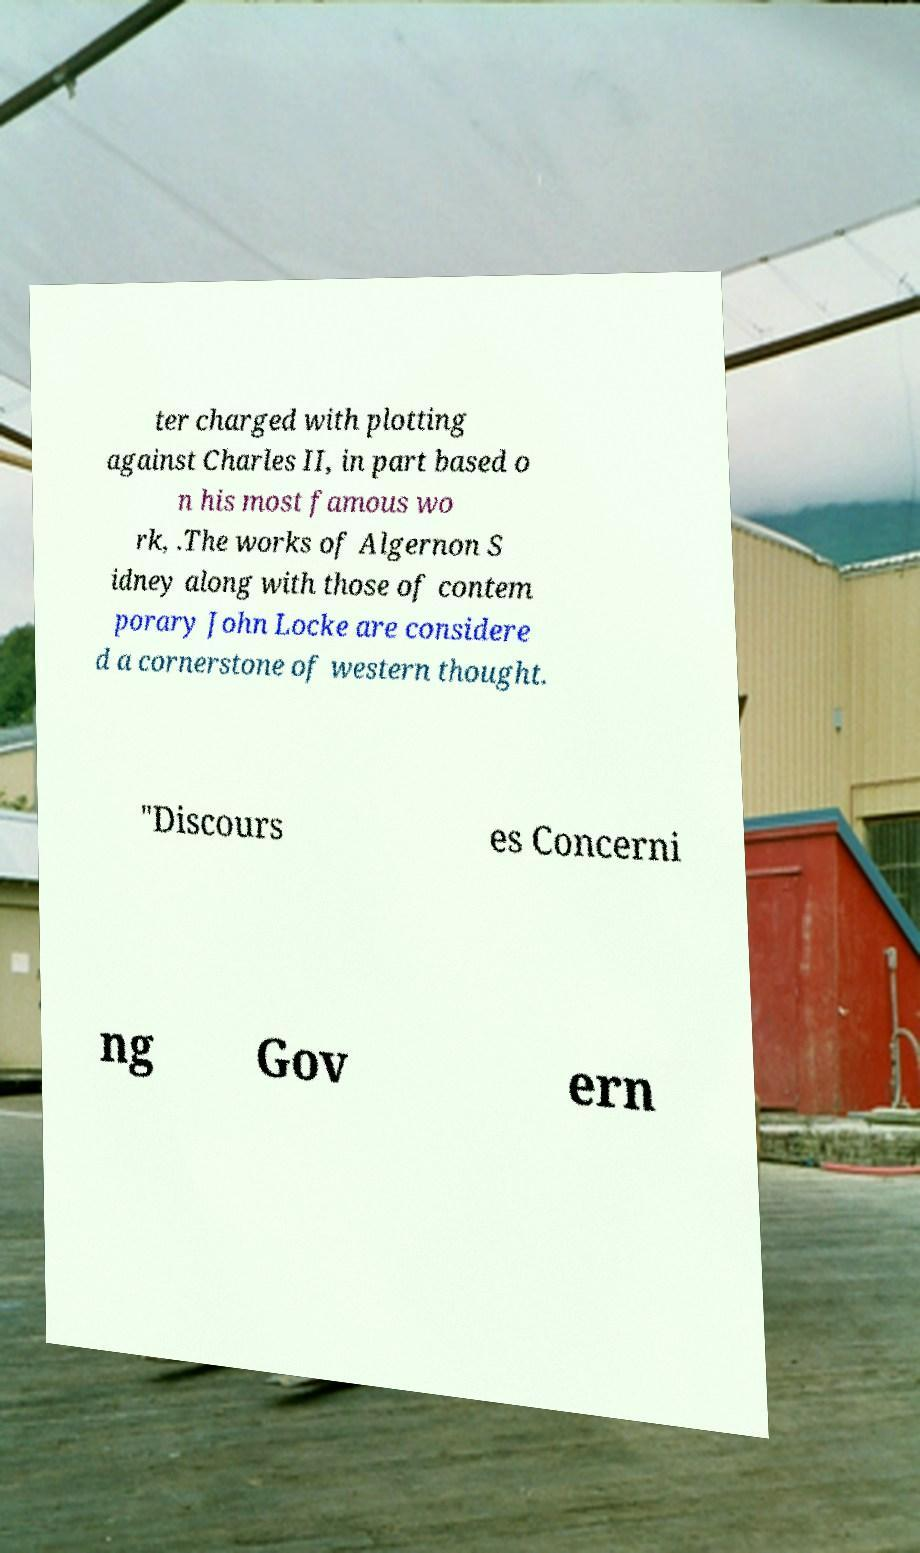There's text embedded in this image that I need extracted. Can you transcribe it verbatim? ter charged with plotting against Charles II, in part based o n his most famous wo rk, .The works of Algernon S idney along with those of contem porary John Locke are considere d a cornerstone of western thought. "Discours es Concerni ng Gov ern 